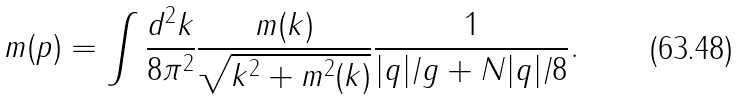Convert formula to latex. <formula><loc_0><loc_0><loc_500><loc_500>m ( p ) = \int \frac { d ^ { 2 } k } { 8 \pi ^ { 2 } } \frac { m ( k ) } { \sqrt { k ^ { 2 } + m ^ { 2 } ( k ) } } \frac { 1 } { | q | / g + N | q | / 8 } .</formula> 